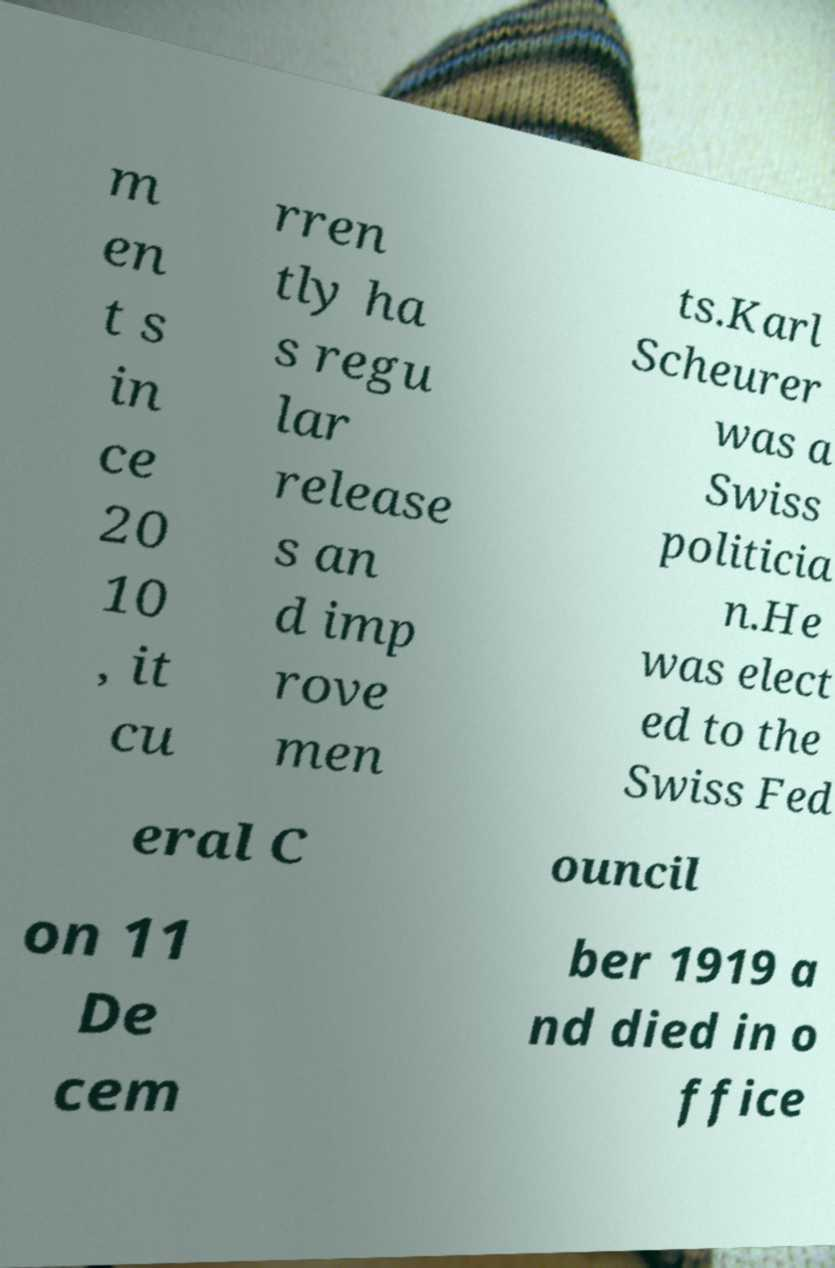Could you assist in decoding the text presented in this image and type it out clearly? m en t s in ce 20 10 , it cu rren tly ha s regu lar release s an d imp rove men ts.Karl Scheurer was a Swiss politicia n.He was elect ed to the Swiss Fed eral C ouncil on 11 De cem ber 1919 a nd died in o ffice 